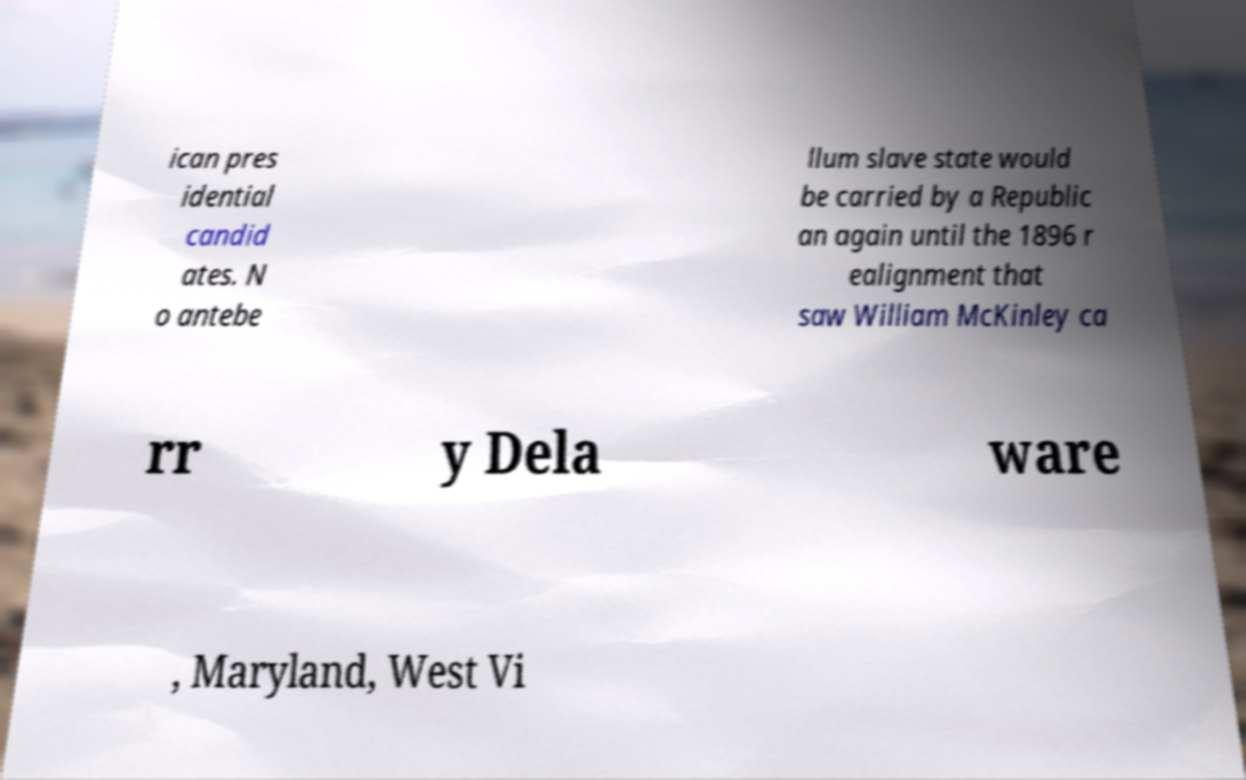I need the written content from this picture converted into text. Can you do that? ican pres idential candid ates. N o antebe llum slave state would be carried by a Republic an again until the 1896 r ealignment that saw William McKinley ca rr y Dela ware , Maryland, West Vi 